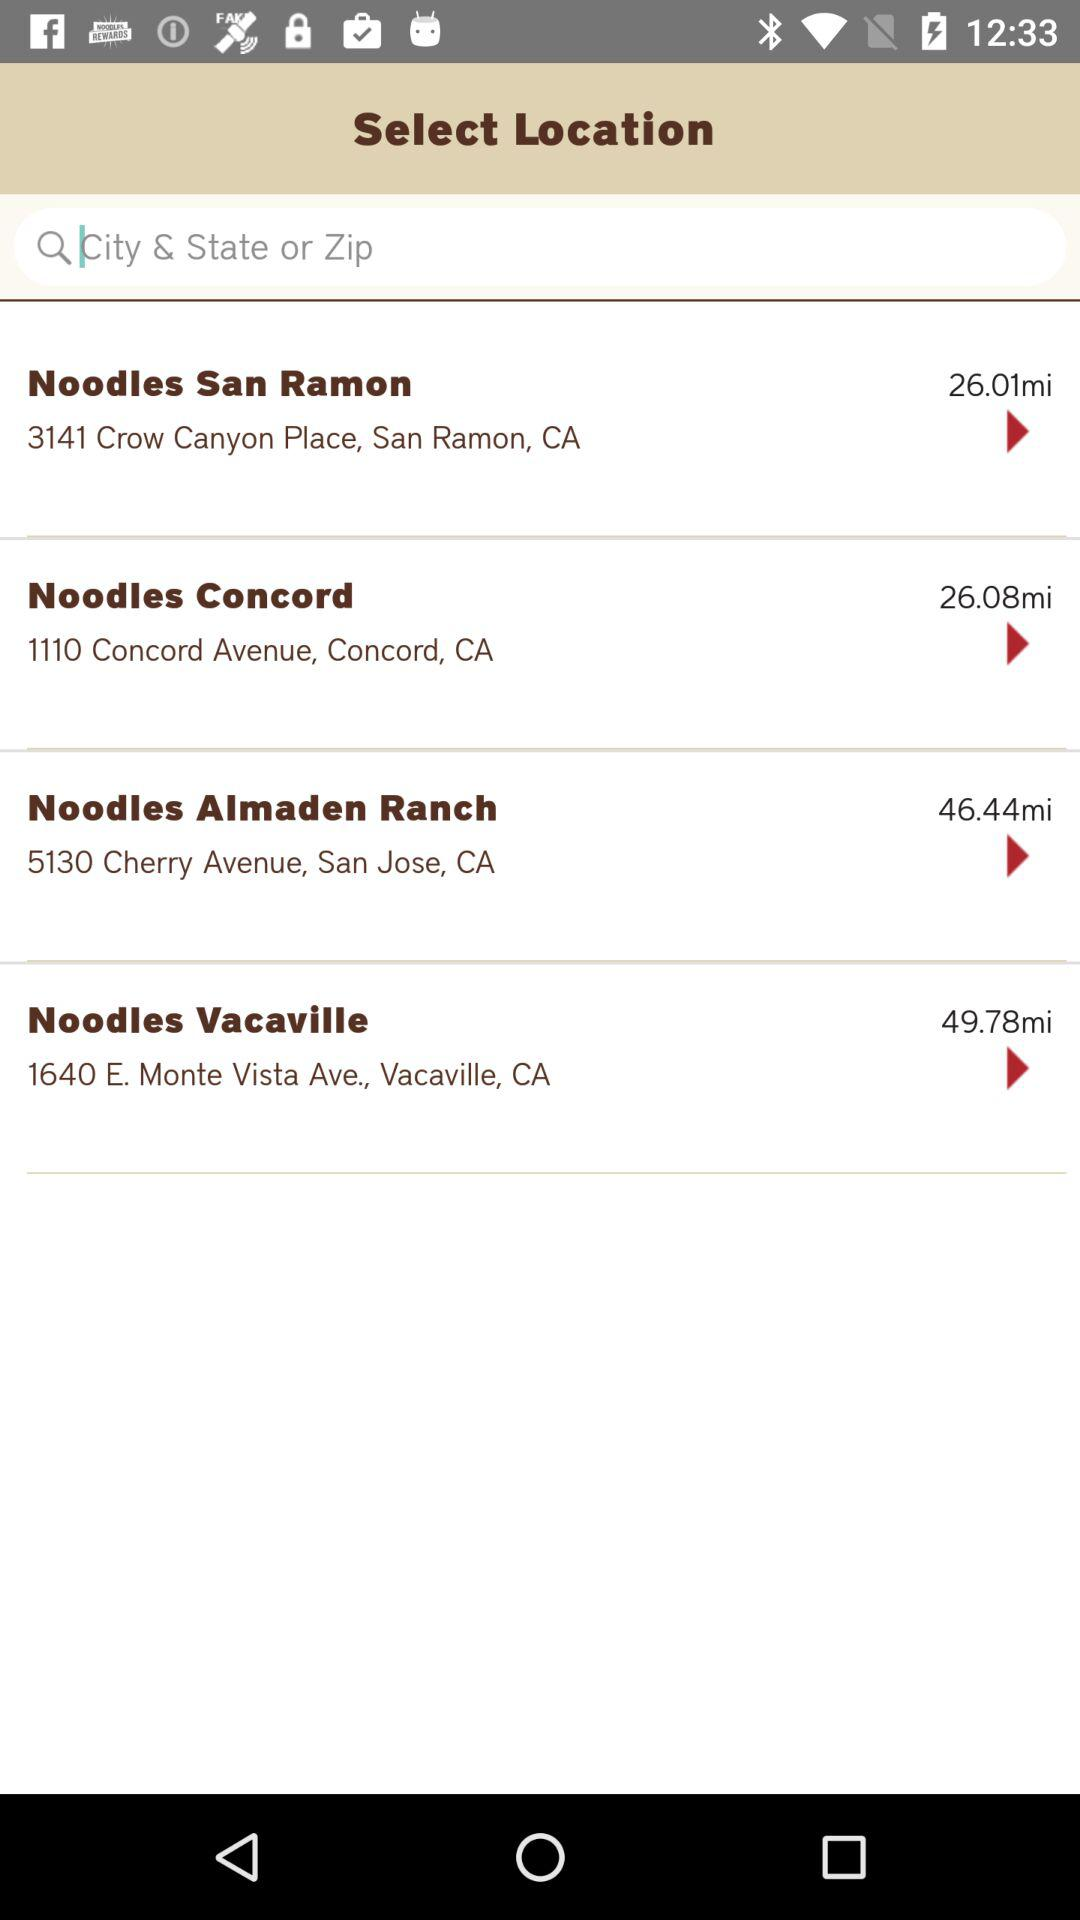How far is the Noodles San Ramon? The Noodles San Ramon is 26.01 miles away. 